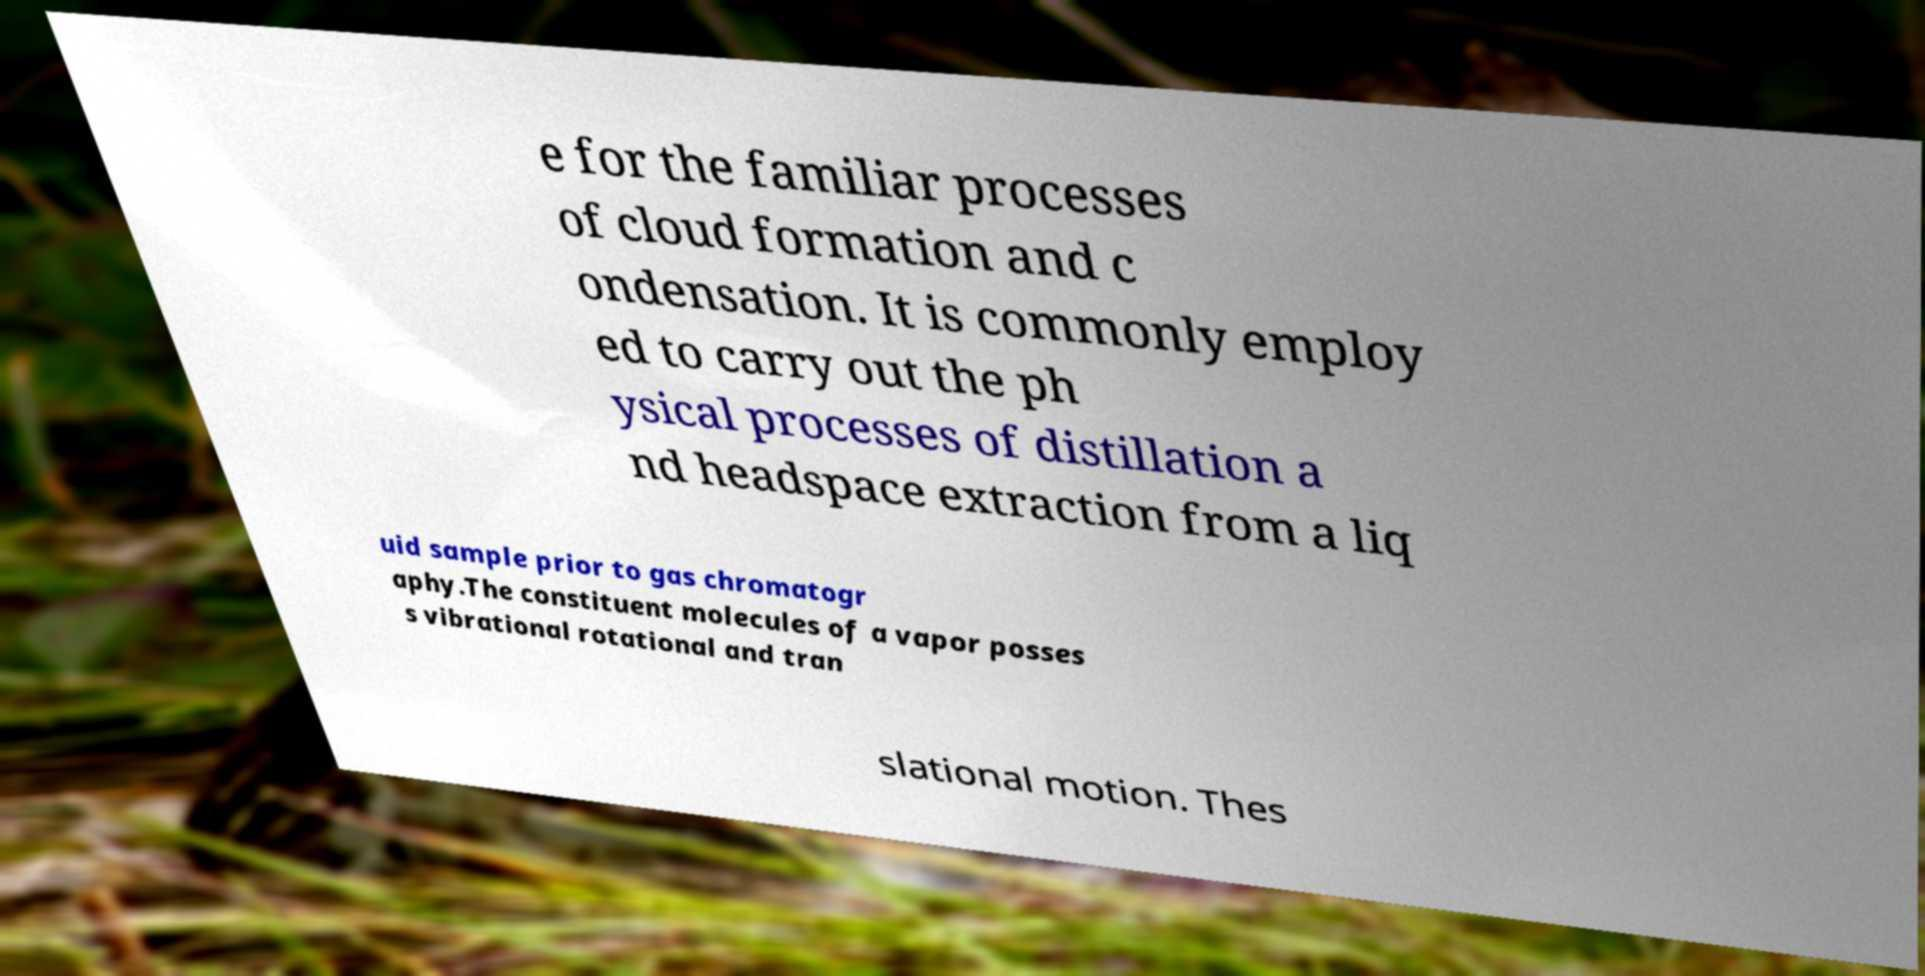For documentation purposes, I need the text within this image transcribed. Could you provide that? e for the familiar processes of cloud formation and c ondensation. It is commonly employ ed to carry out the ph ysical processes of distillation a nd headspace extraction from a liq uid sample prior to gas chromatogr aphy.The constituent molecules of a vapor posses s vibrational rotational and tran slational motion. Thes 